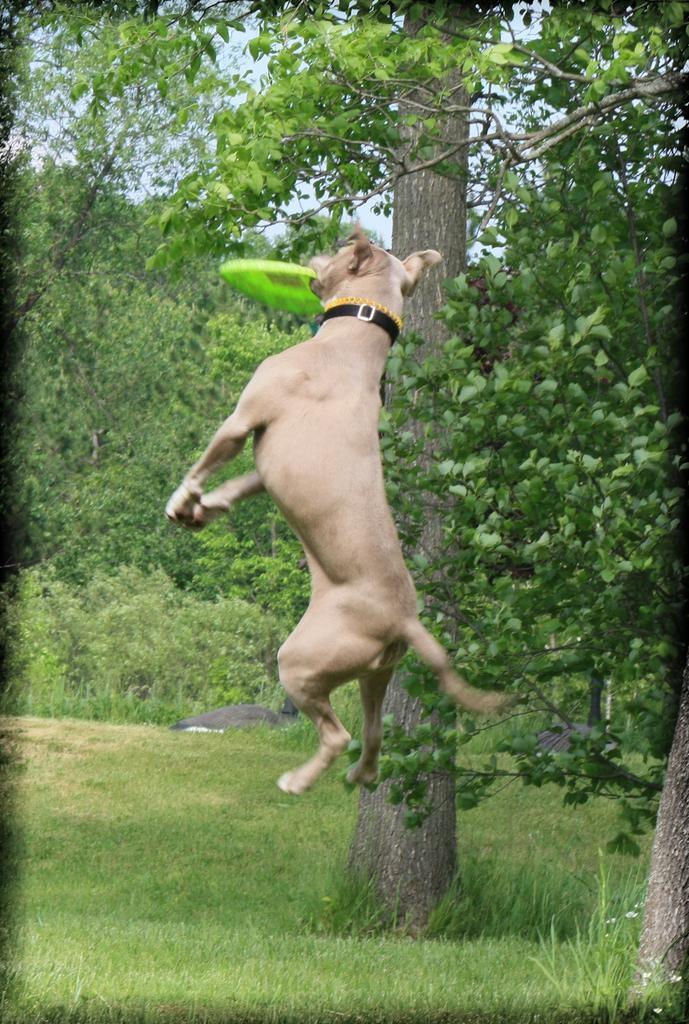Could you give a brief overview of what you see in this image? In the middle I can see a dog is holding a disc in mouth. In the background I can see grass, trees and the sky. This image is taken in a park during a day. 